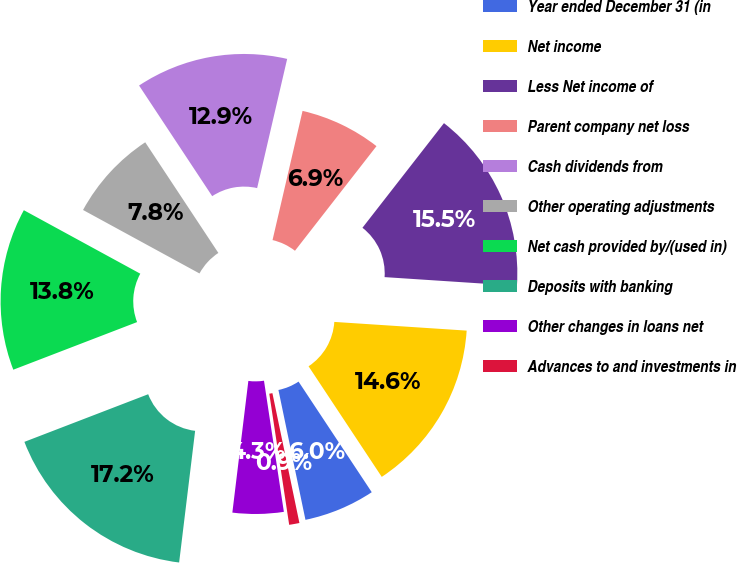Convert chart to OTSL. <chart><loc_0><loc_0><loc_500><loc_500><pie_chart><fcel>Year ended December 31 (in<fcel>Net income<fcel>Less Net income of<fcel>Parent company net loss<fcel>Cash dividends from<fcel>Other operating adjustments<fcel>Net cash provided by/(used in)<fcel>Deposits with banking<fcel>Other changes in loans net<fcel>Advances to and investments in<nl><fcel>6.04%<fcel>14.65%<fcel>15.51%<fcel>6.9%<fcel>12.93%<fcel>7.76%<fcel>13.79%<fcel>17.23%<fcel>4.32%<fcel>0.87%<nl></chart> 